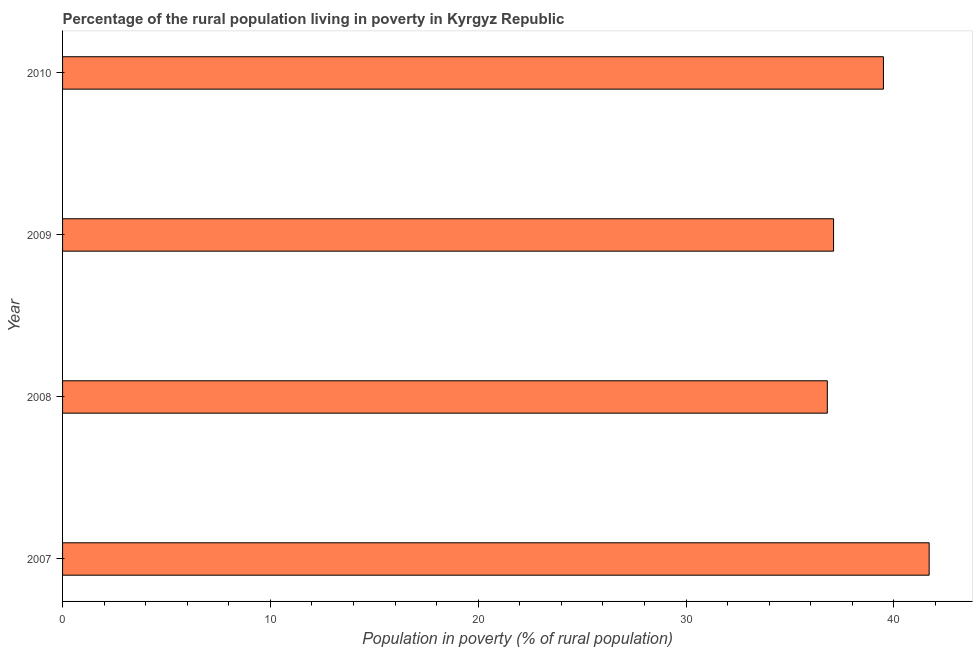Does the graph contain any zero values?
Your answer should be very brief. No. Does the graph contain grids?
Ensure brevity in your answer.  No. What is the title of the graph?
Ensure brevity in your answer.  Percentage of the rural population living in poverty in Kyrgyz Republic. What is the label or title of the X-axis?
Provide a succinct answer. Population in poverty (% of rural population). What is the percentage of rural population living below poverty line in 2010?
Provide a succinct answer. 39.5. Across all years, what is the maximum percentage of rural population living below poverty line?
Give a very brief answer. 41.7. Across all years, what is the minimum percentage of rural population living below poverty line?
Your response must be concise. 36.8. What is the sum of the percentage of rural population living below poverty line?
Offer a terse response. 155.1. What is the average percentage of rural population living below poverty line per year?
Provide a succinct answer. 38.77. What is the median percentage of rural population living below poverty line?
Give a very brief answer. 38.3. In how many years, is the percentage of rural population living below poverty line greater than 24 %?
Give a very brief answer. 4. Do a majority of the years between 2008 and 2007 (inclusive) have percentage of rural population living below poverty line greater than 12 %?
Ensure brevity in your answer.  No. What is the ratio of the percentage of rural population living below poverty line in 2007 to that in 2008?
Your response must be concise. 1.13. Is the difference between the percentage of rural population living below poverty line in 2007 and 2008 greater than the difference between any two years?
Offer a terse response. Yes. What is the difference between the highest and the second highest percentage of rural population living below poverty line?
Your answer should be compact. 2.2. In how many years, is the percentage of rural population living below poverty line greater than the average percentage of rural population living below poverty line taken over all years?
Provide a succinct answer. 2. Are all the bars in the graph horizontal?
Your answer should be very brief. Yes. Are the values on the major ticks of X-axis written in scientific E-notation?
Provide a succinct answer. No. What is the Population in poverty (% of rural population) in 2007?
Ensure brevity in your answer.  41.7. What is the Population in poverty (% of rural population) of 2008?
Your response must be concise. 36.8. What is the Population in poverty (% of rural population) in 2009?
Offer a very short reply. 37.1. What is the Population in poverty (% of rural population) of 2010?
Offer a very short reply. 39.5. What is the difference between the Population in poverty (% of rural population) in 2007 and 2008?
Your response must be concise. 4.9. What is the difference between the Population in poverty (% of rural population) in 2007 and 2010?
Your response must be concise. 2.2. What is the ratio of the Population in poverty (% of rural population) in 2007 to that in 2008?
Your answer should be compact. 1.13. What is the ratio of the Population in poverty (% of rural population) in 2007 to that in 2009?
Offer a very short reply. 1.12. What is the ratio of the Population in poverty (% of rural population) in 2007 to that in 2010?
Offer a very short reply. 1.06. What is the ratio of the Population in poverty (% of rural population) in 2008 to that in 2009?
Keep it short and to the point. 0.99. What is the ratio of the Population in poverty (% of rural population) in 2008 to that in 2010?
Provide a succinct answer. 0.93. What is the ratio of the Population in poverty (% of rural population) in 2009 to that in 2010?
Make the answer very short. 0.94. 